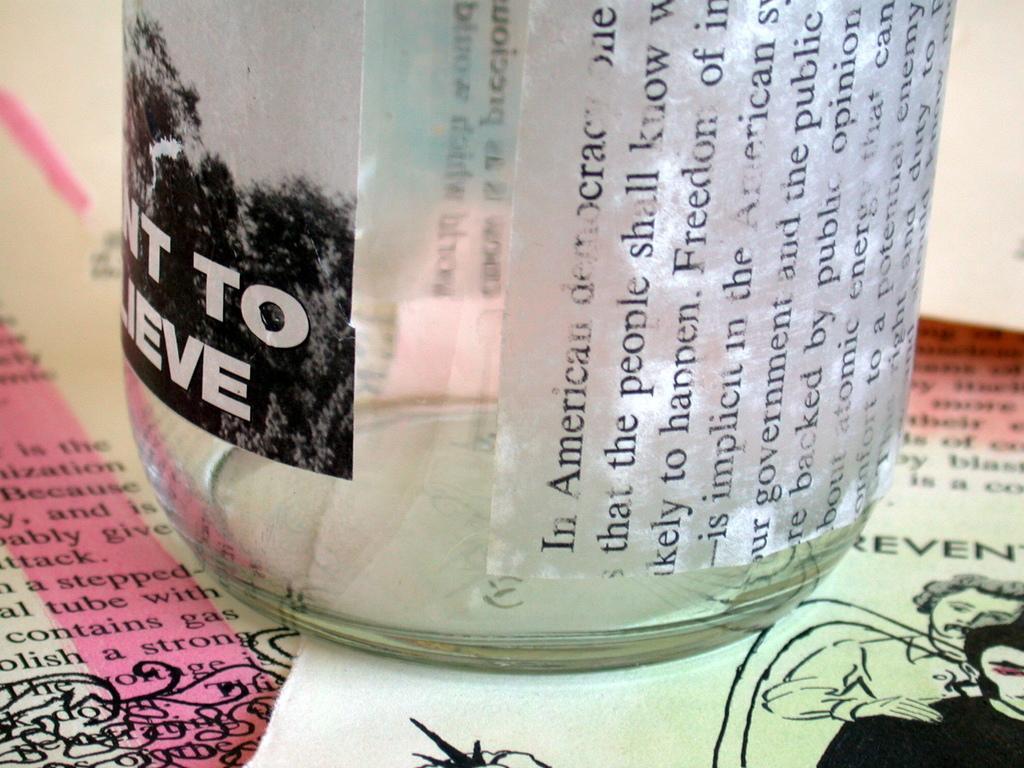Can you describe this image briefly? In this image there is a bottle on the papers. Bottle is having some text on it. Right side there are few images of two persons and some text on the paper. 